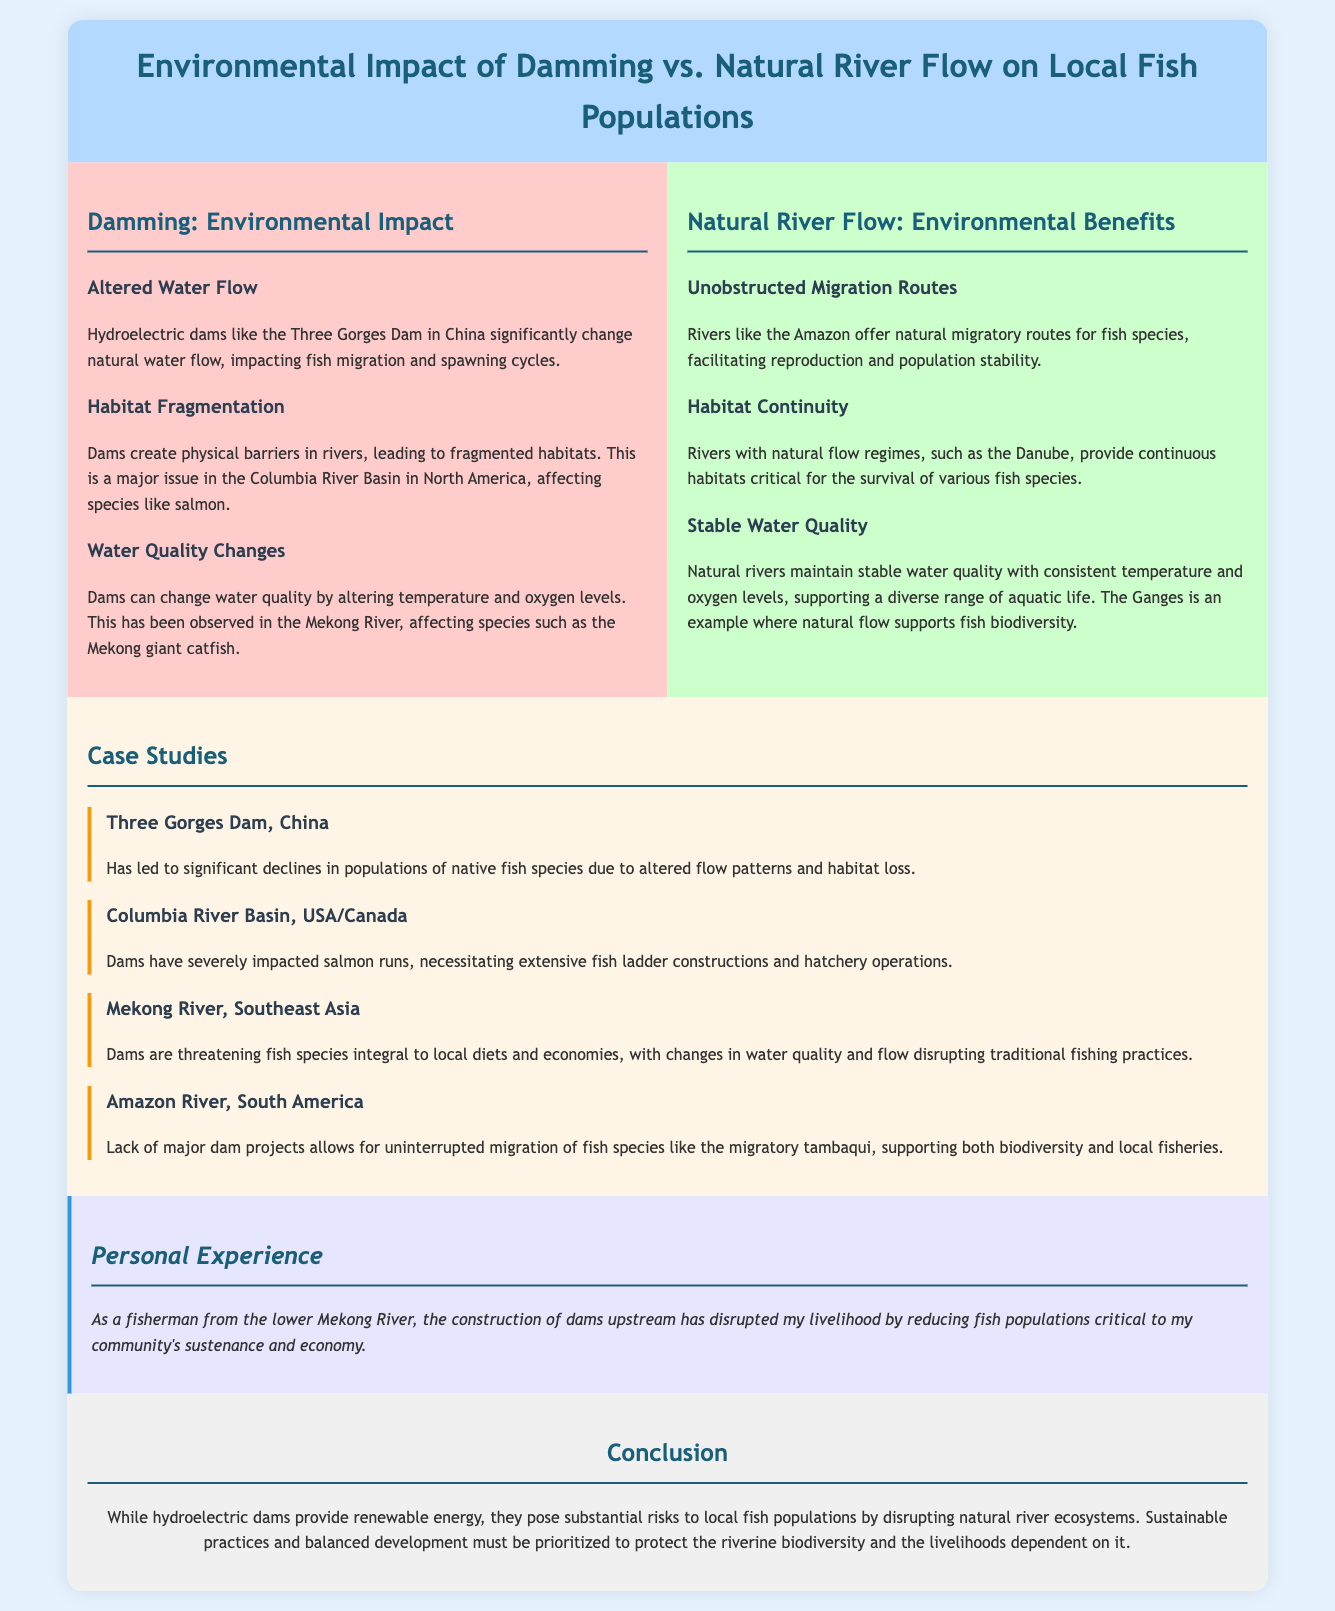What is the title of the infographic? The title is displayed prominently at the top of the document, which is "Environmental Impact of Damming vs. Natural River Flow on Local Fish Populations."
Answer: Environmental Impact of Damming vs. Natural River Flow on Local Fish Populations What is one major issue caused by dams in the Columbia River Basin? The document mentions that dams lead to habitat fragmentation, significantly impacting species like salmon in the Columbia River Basin.
Answer: Habitat fragmentation Which species is significantly affected by the Mekong River dam construction? The document states that the Mekong giant catfish is among the species affected by changes in water quality due to dams on the Mekong River.
Answer: Mekong giant catfish What river is cited as maintaining stable water quality? The document highlights the Ganges River as an example where natural flow supports fish biodiversity due to stable water quality.
Answer: Ganges What is cited as a benefit of natural river flow? The infographic points out that unobstructed migration routes are a benefit of natural river flow for fish species.
Answer: Unobstructed migration routes What type of case study involves the Amazon River? The case study for the Amazon River indicates that a lack of major dam projects allows for uninterrupted migration of fish species.
Answer: Lack of major dam projects What personal experience is shared in the document? The document includes a personal experience related to the construction of dams disrupting fish populations critical to local communities.
Answer: Disrupted fish populations What is the conclusion regarding hydroelectric dams? The conclusion states that while hydroelectric dams provide renewable energy, they pose significant risks to local fish populations.
Answer: Significant risks to local fish populations 